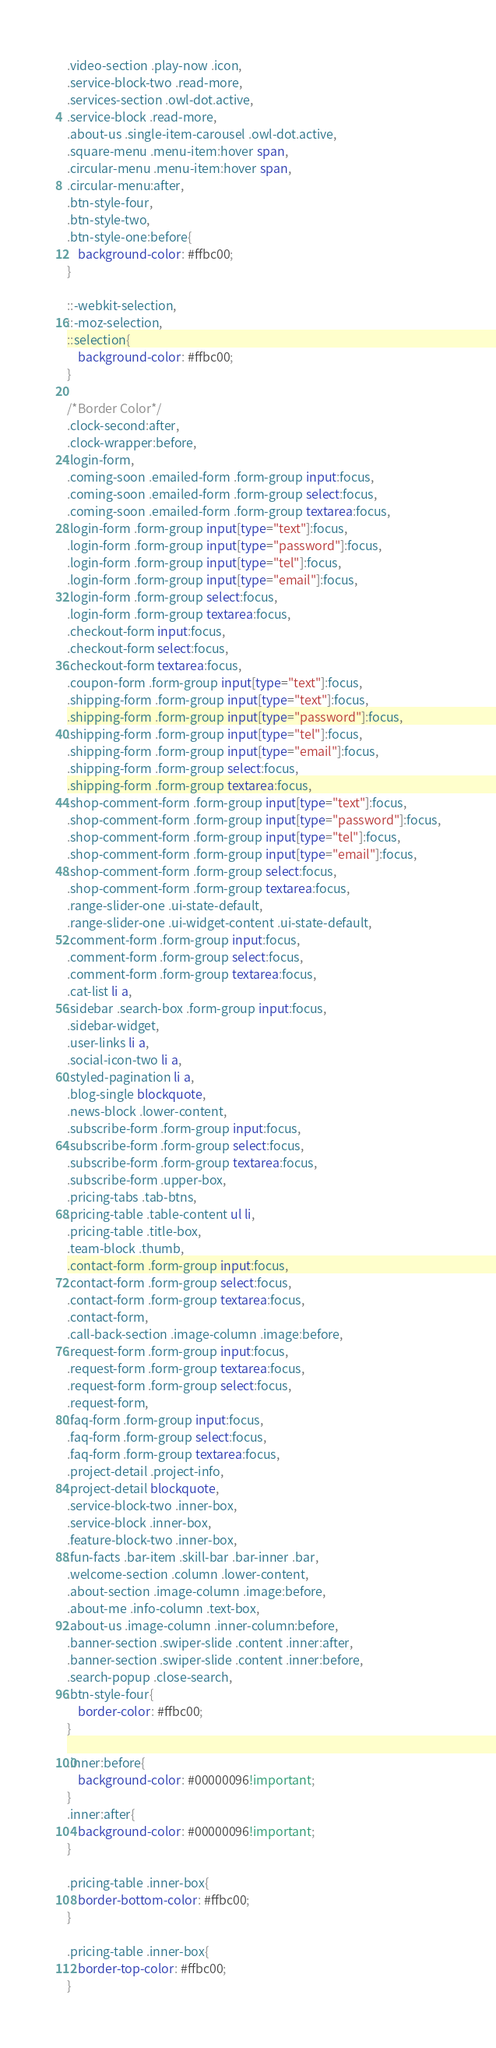Convert code to text. <code><loc_0><loc_0><loc_500><loc_500><_CSS_>.video-section .play-now .icon,
.service-block-two .read-more,
.services-section .owl-dot.active,
.service-block .read-more,
.about-us .single-item-carousel .owl-dot.active,
.square-menu .menu-item:hover span,
.circular-menu .menu-item:hover span,
.circular-menu:after,
.btn-style-four,
.btn-style-two,
.btn-style-one:before{
	background-color: #ffbc00;
}

::-webkit-selection,
::-moz-selection,
::selection{
	background-color: #ffbc00;
}

/*Border Color*/
.clock-second:after,
.clock-wrapper:before,
.login-form,
.coming-soon .emailed-form .form-group input:focus,
.coming-soon .emailed-form .form-group select:focus,
.coming-soon .emailed-form .form-group textarea:focus,
.login-form .form-group input[type="text"]:focus,
.login-form .form-group input[type="password"]:focus,
.login-form .form-group input[type="tel"]:focus,
.login-form .form-group input[type="email"]:focus,
.login-form .form-group select:focus,
.login-form .form-group textarea:focus,
.checkout-form input:focus,
.checkout-form select:focus,
.checkout-form textarea:focus,
.coupon-form .form-group input[type="text"]:focus,
.shipping-form .form-group input[type="text"]:focus,
.shipping-form .form-group input[type="password"]:focus,
.shipping-form .form-group input[type="tel"]:focus,
.shipping-form .form-group input[type="email"]:focus,
.shipping-form .form-group select:focus,
.shipping-form .form-group textarea:focus,
.shop-comment-form .form-group input[type="text"]:focus,
.shop-comment-form .form-group input[type="password"]:focus,
.shop-comment-form .form-group input[type="tel"]:focus,
.shop-comment-form .form-group input[type="email"]:focus,
.shop-comment-form .form-group select:focus,
.shop-comment-form .form-group textarea:focus,
.range-slider-one .ui-state-default,
.range-slider-one .ui-widget-content .ui-state-default,
.comment-form .form-group input:focus,
.comment-form .form-group select:focus,
.comment-form .form-group textarea:focus,
.cat-list li a,
.sidebar .search-box .form-group input:focus,
.sidebar-widget,
.user-links li a,
.social-icon-two li a,
.styled-pagination li a,
.blog-single blockquote,
.news-block .lower-content,
.subscribe-form .form-group input:focus,
.subscribe-form .form-group select:focus,
.subscribe-form .form-group textarea:focus,
.subscribe-form .upper-box,
.pricing-tabs .tab-btns,
.pricing-table .table-content ul li,
.pricing-table .title-box,
.team-block .thumb,
.contact-form .form-group input:focus,
.contact-form .form-group select:focus,
.contact-form .form-group textarea:focus,
.contact-form,
.call-back-section .image-column .image:before,
.request-form .form-group input:focus,
.request-form .form-group textarea:focus,
.request-form .form-group select:focus,
.request-form,
.faq-form .form-group input:focus,
.faq-form .form-group select:focus,
.faq-form .form-group textarea:focus,
.project-detail .project-info,
.project-detail blockquote,
.service-block-two .inner-box,
.service-block .inner-box,
.feature-block-two .inner-box,
.fun-facts .bar-item .skill-bar .bar-inner .bar,
.welcome-section .column .lower-content,
.about-section .image-column .image:before,
.about-me .info-column .text-box,
.about-us .image-column .inner-column:before,
.banner-section .swiper-slide .content .inner:after,
.banner-section .swiper-slide .content .inner:before,
.search-popup .close-search,
.btn-style-four{
	border-color: #ffbc00;
}

.inner:before{
    background-color: #00000096!important;
}
.inner:after{
    background-color: #00000096!important;
}

.pricing-table .inner-box{
	border-bottom-color: #ffbc00;
}

.pricing-table .inner-box{
	border-top-color: #ffbc00;
}</code> 